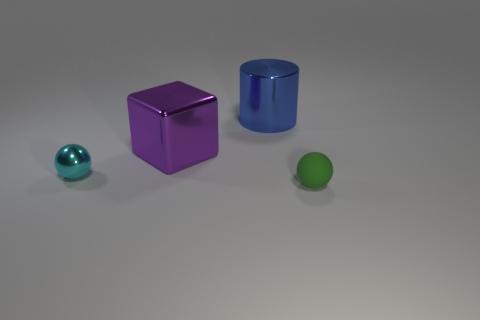Add 2 purple objects. How many objects exist? 6 Subtract all blocks. How many objects are left? 3 Add 4 tiny shiny spheres. How many tiny shiny spheres exist? 5 Subtract 1 blue cylinders. How many objects are left? 3 Subtract all tiny cyan shiny things. Subtract all large blue things. How many objects are left? 2 Add 1 cubes. How many cubes are left? 2 